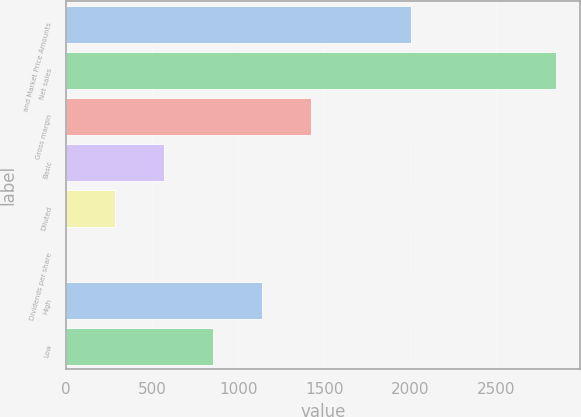Convert chart. <chart><loc_0><loc_0><loc_500><loc_500><bar_chart><fcel>and Market Price Amounts<fcel>Net sales<fcel>Gross margin<fcel>Basic<fcel>Diluted<fcel>Dividends per share<fcel>High<fcel>Low<nl><fcel>2006<fcel>2845<fcel>1422.69<fcel>569.28<fcel>284.81<fcel>0.34<fcel>1138.22<fcel>853.75<nl></chart> 